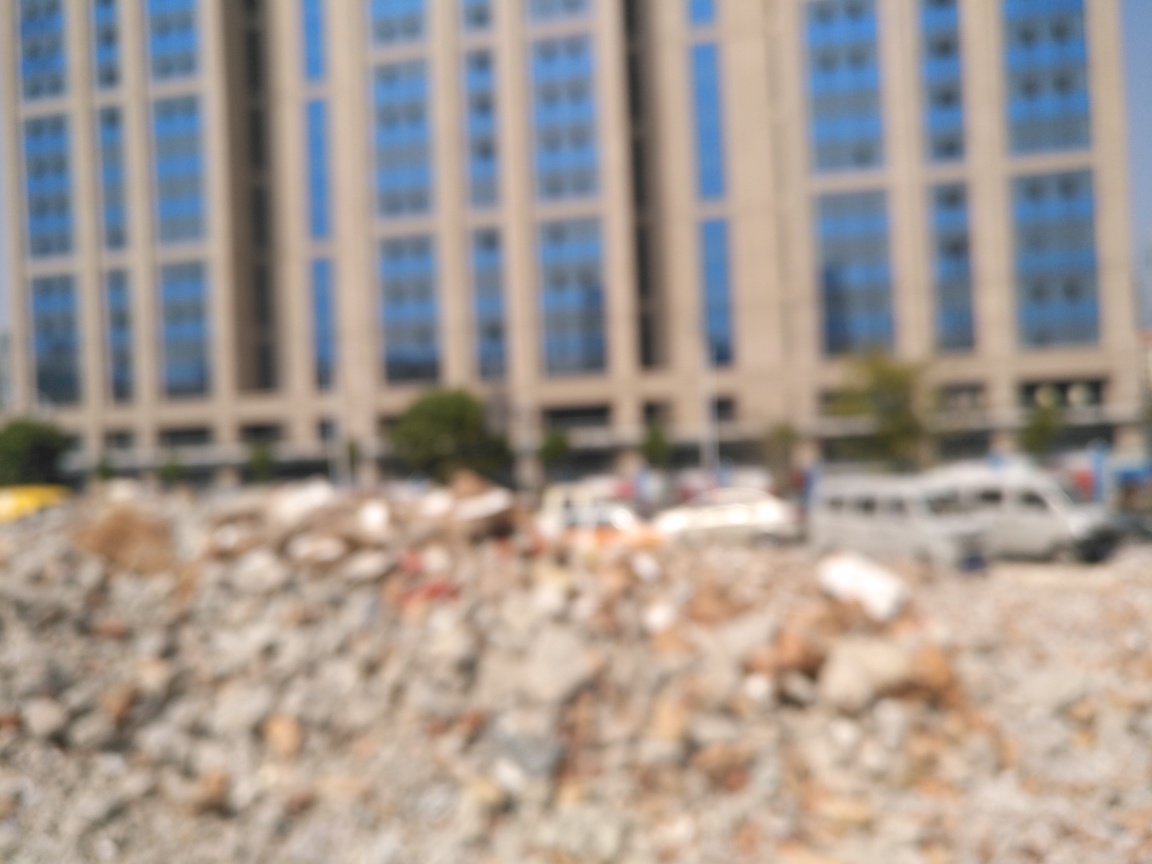Is the image clear?
A. Yes
B. No
Answer with the option's letter from the given choices directly.
 B. 